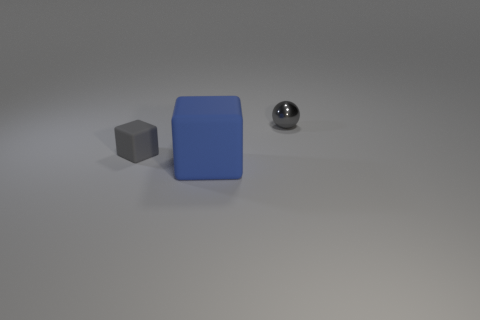Are there any other things that have the same size as the blue rubber block?
Provide a short and direct response. No. Are there any other things that have the same material as the gray ball?
Make the answer very short. No. How many shiny balls have the same size as the blue rubber cube?
Give a very brief answer. 0. There is another thing that is the same shape as the blue object; what material is it?
Keep it short and to the point. Rubber. What number of objects are tiny objects on the left side of the metal thing or objects that are behind the large blue matte block?
Provide a succinct answer. 2. Is the shape of the blue rubber thing the same as the tiny object in front of the shiny object?
Your response must be concise. Yes. There is a rubber object that is in front of the tiny thing that is to the left of the rubber thing on the right side of the tiny rubber thing; what is its shape?
Provide a succinct answer. Cube. How many other things are there of the same material as the gray sphere?
Offer a very short reply. 0. What number of objects are things on the right side of the blue rubber cube or gray objects?
Keep it short and to the point. 2. There is a tiny object that is behind the block behind the large thing; what shape is it?
Your response must be concise. Sphere. 